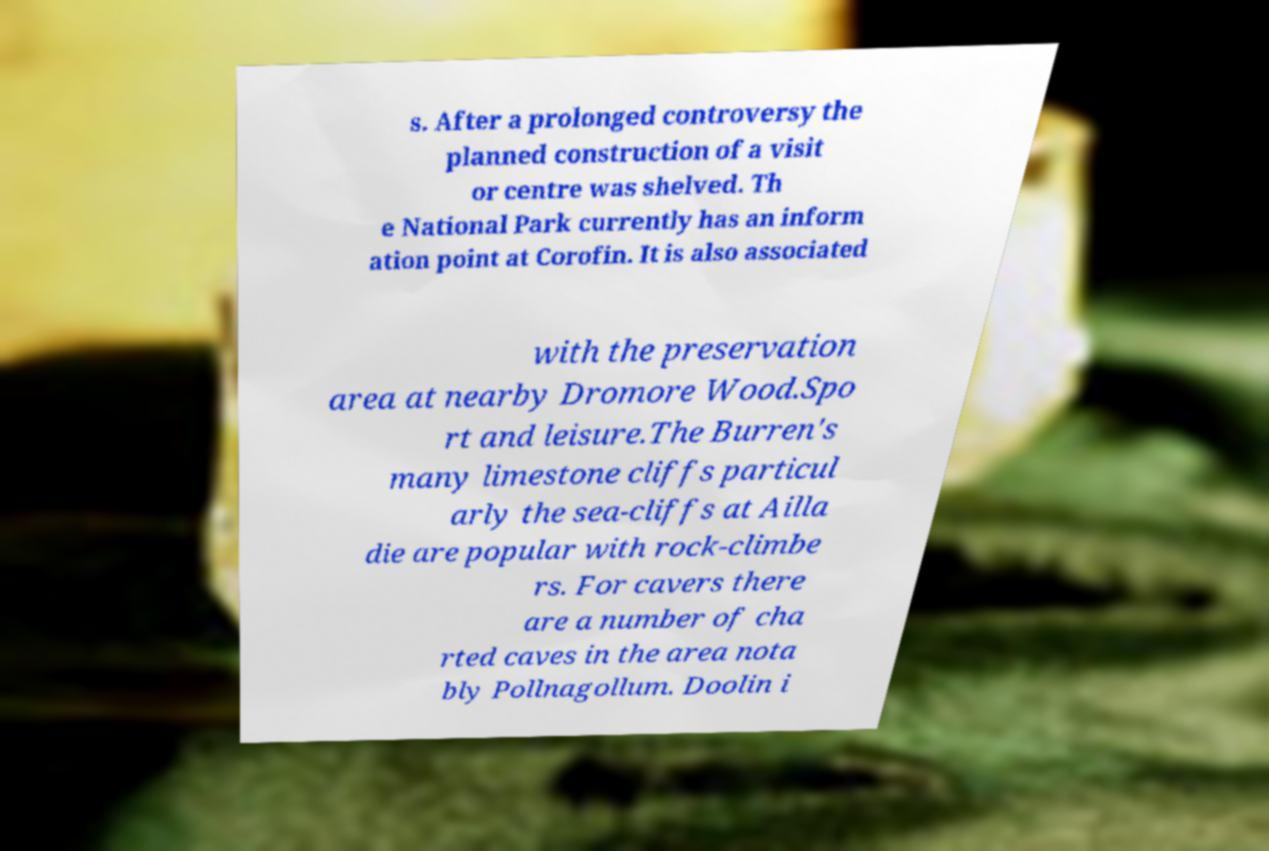There's text embedded in this image that I need extracted. Can you transcribe it verbatim? s. After a prolonged controversy the planned construction of a visit or centre was shelved. Th e National Park currently has an inform ation point at Corofin. It is also associated with the preservation area at nearby Dromore Wood.Spo rt and leisure.The Burren's many limestone cliffs particul arly the sea-cliffs at Ailla die are popular with rock-climbe rs. For cavers there are a number of cha rted caves in the area nota bly Pollnagollum. Doolin i 